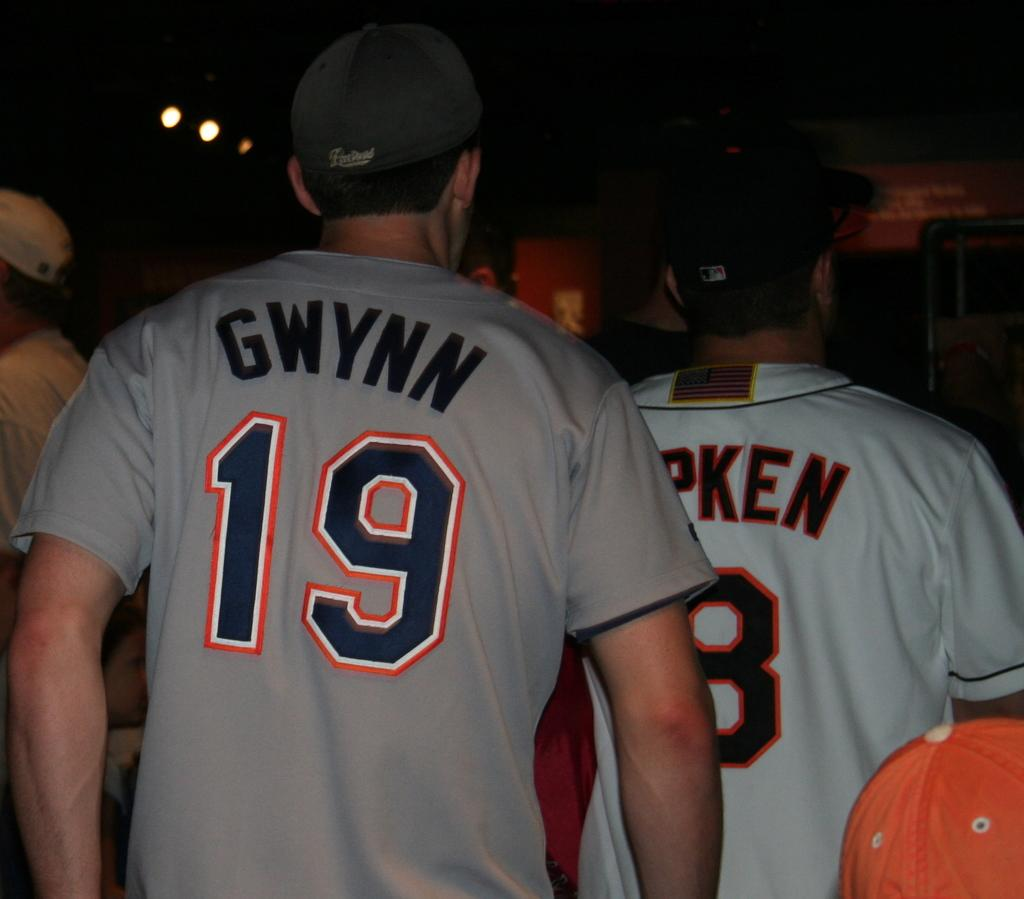<image>
Summarize the visual content of the image. The back of fans wearing GWYNN 19 shirt and baseball caps exit. 